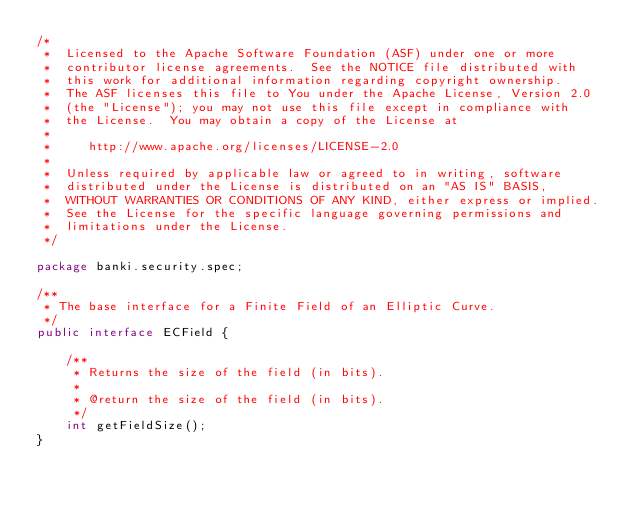<code> <loc_0><loc_0><loc_500><loc_500><_Java_>/*
 *  Licensed to the Apache Software Foundation (ASF) under one or more
 *  contributor license agreements.  See the NOTICE file distributed with
 *  this work for additional information regarding copyright ownership.
 *  The ASF licenses this file to You under the Apache License, Version 2.0
 *  (the "License"); you may not use this file except in compliance with
 *  the License.  You may obtain a copy of the License at
 *
 *     http://www.apache.org/licenses/LICENSE-2.0
 *
 *  Unless required by applicable law or agreed to in writing, software
 *  distributed under the License is distributed on an "AS IS" BASIS,
 *  WITHOUT WARRANTIES OR CONDITIONS OF ANY KIND, either express or implied.
 *  See the License for the specific language governing permissions and
 *  limitations under the License.
 */

package banki.security.spec;

/**
 * The base interface for a Finite Field of an Elliptic Curve.
 */
public interface ECField {

    /**
     * Returns the size of the field (in bits).
     *
     * @return the size of the field (in bits).
     */
    int getFieldSize();
}
</code> 